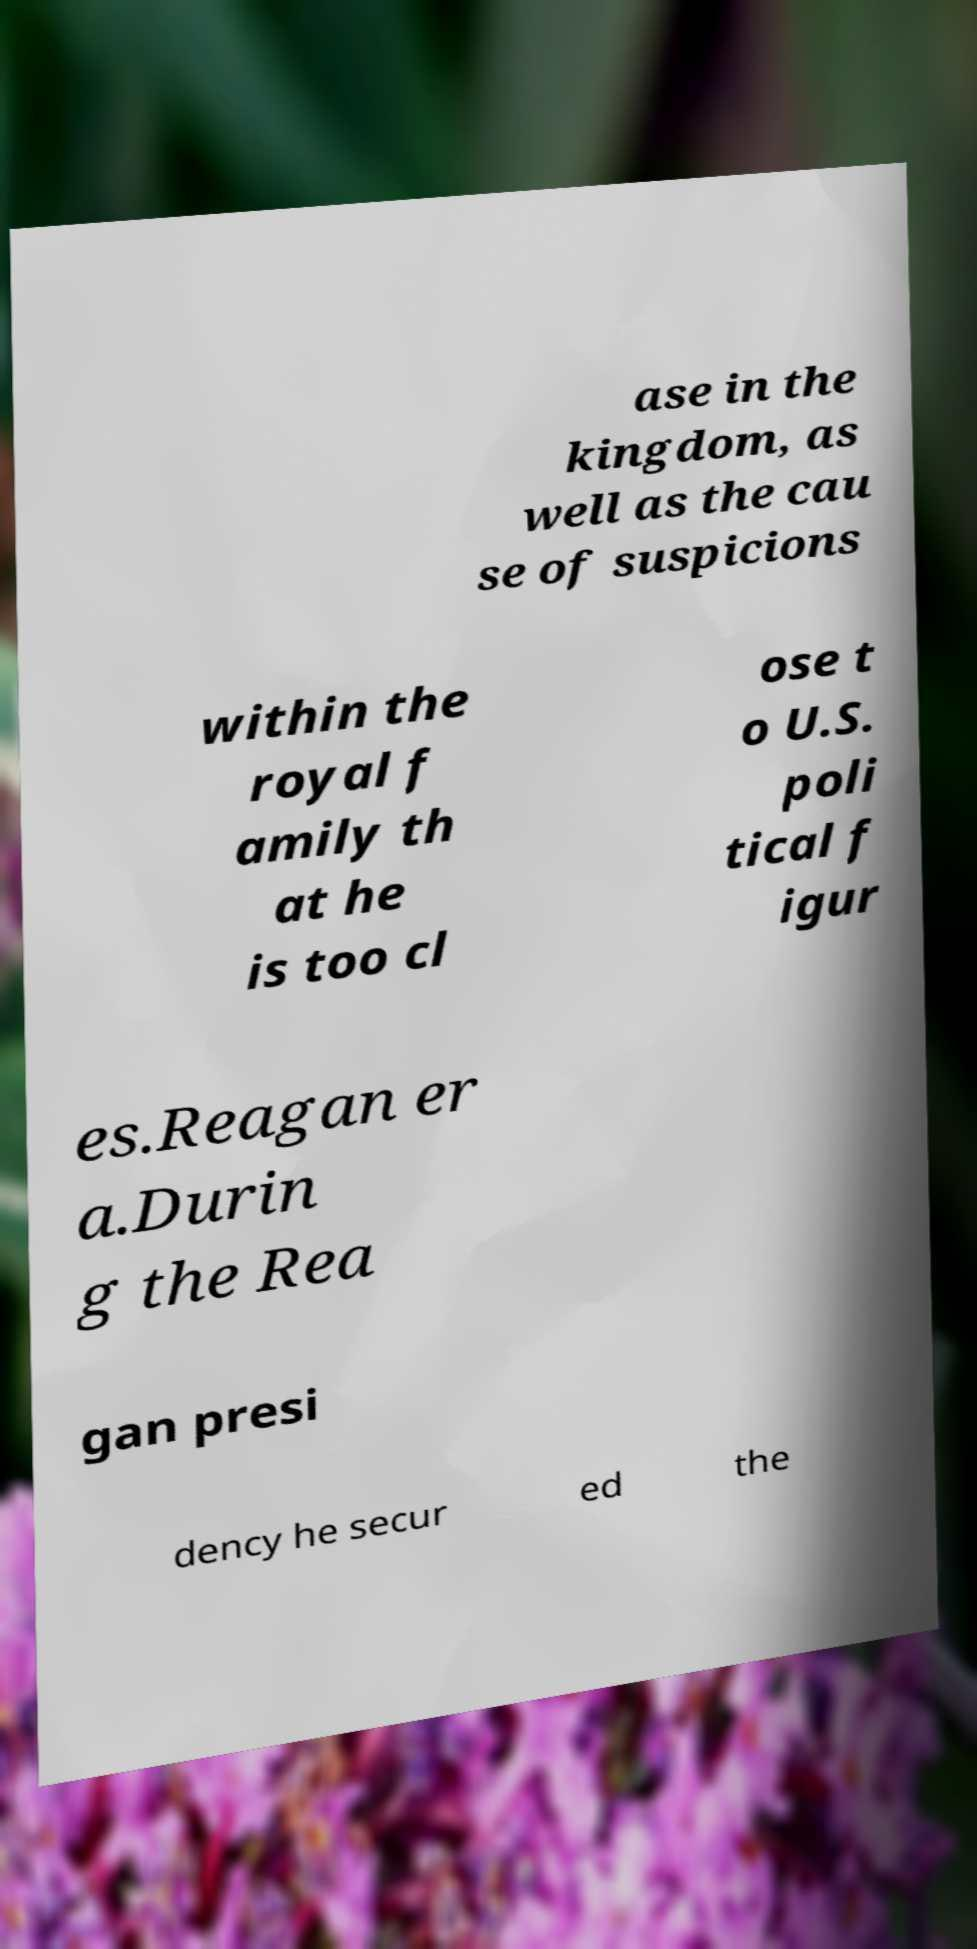Can you accurately transcribe the text from the provided image for me? ase in the kingdom, as well as the cau se of suspicions within the royal f amily th at he is too cl ose t o U.S. poli tical f igur es.Reagan er a.Durin g the Rea gan presi dency he secur ed the 